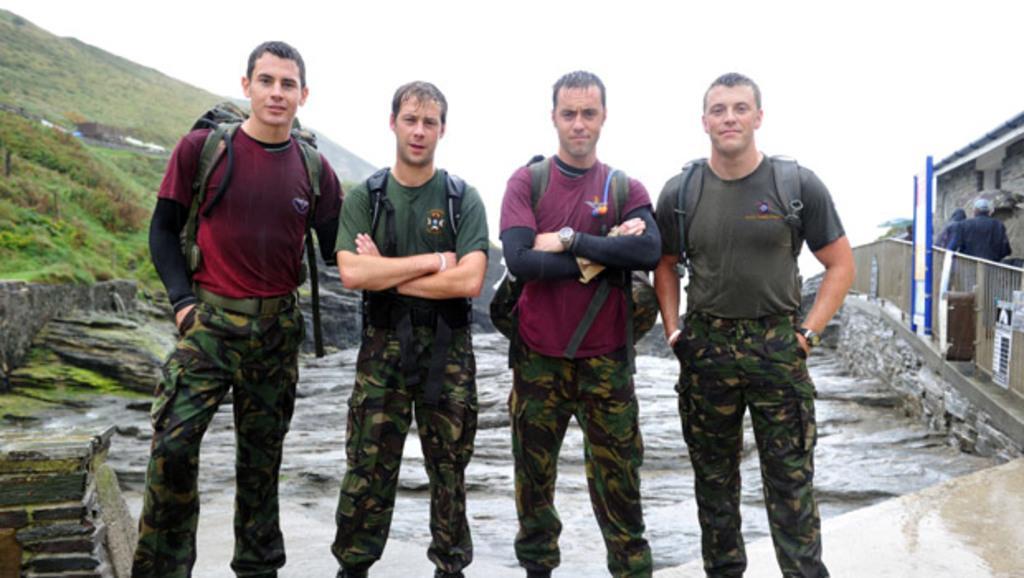Could you give a brief overview of what you see in this image? In front of the picture, we see four men in the uniform are standing. They are posing for the photo. On the left side, we see the rocks, grass and hills. On the right side, we see the railing and the people are walking. Beside them, we see a building which is made up of stones. At the top, we see the sky. It might be an edited image. 